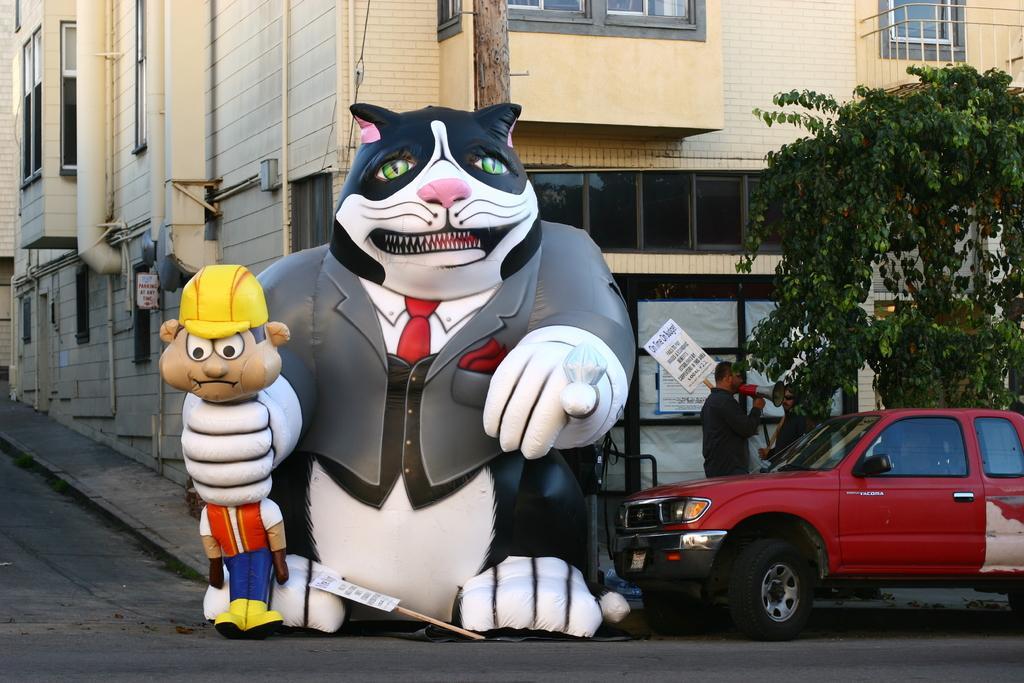Describe this image in one or two sentences. In the picture we can see a street with road, building and near to it, we can see a tree and a man standing near to it and on the road we can see a car which is red in color and to the path we can also see a big doll holding a small doll and to the building we can see some pipes. 